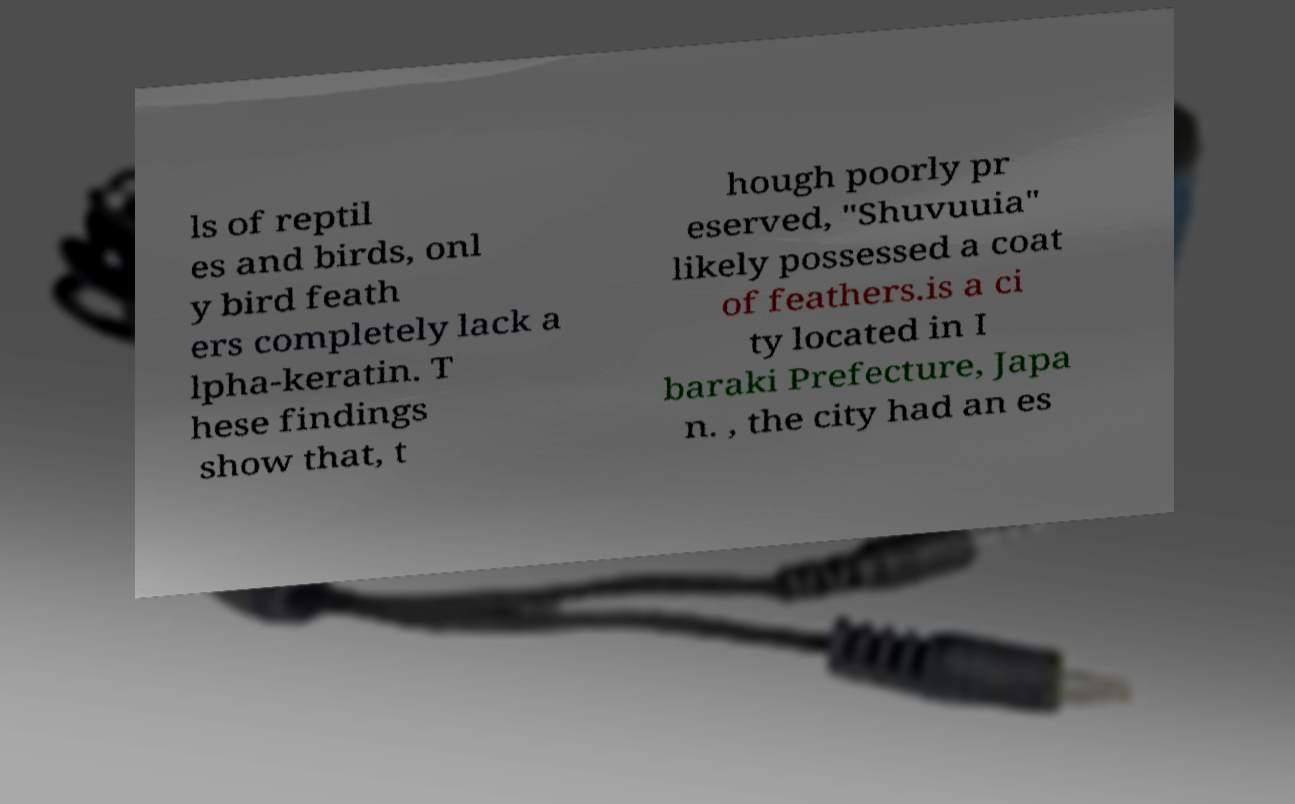Can you read and provide the text displayed in the image?This photo seems to have some interesting text. Can you extract and type it out for me? ls of reptil es and birds, onl y bird feath ers completely lack a lpha-keratin. T hese findings show that, t hough poorly pr eserved, "Shuvuuia" likely possessed a coat of feathers.is a ci ty located in I baraki Prefecture, Japa n. , the city had an es 